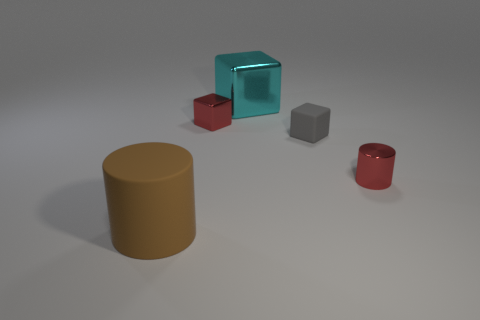Add 5 brown cylinders. How many objects exist? 10 Subtract all shiny cubes. How many cubes are left? 1 Add 5 gray objects. How many gray objects exist? 6 Subtract all cyan cubes. How many cubes are left? 2 Subtract 0 blue blocks. How many objects are left? 5 Subtract all cylinders. How many objects are left? 3 Subtract 1 cylinders. How many cylinders are left? 1 Subtract all gray cylinders. Subtract all red blocks. How many cylinders are left? 2 Subtract all cyan cylinders. How many red blocks are left? 1 Subtract all big rubber cylinders. Subtract all large shiny cubes. How many objects are left? 3 